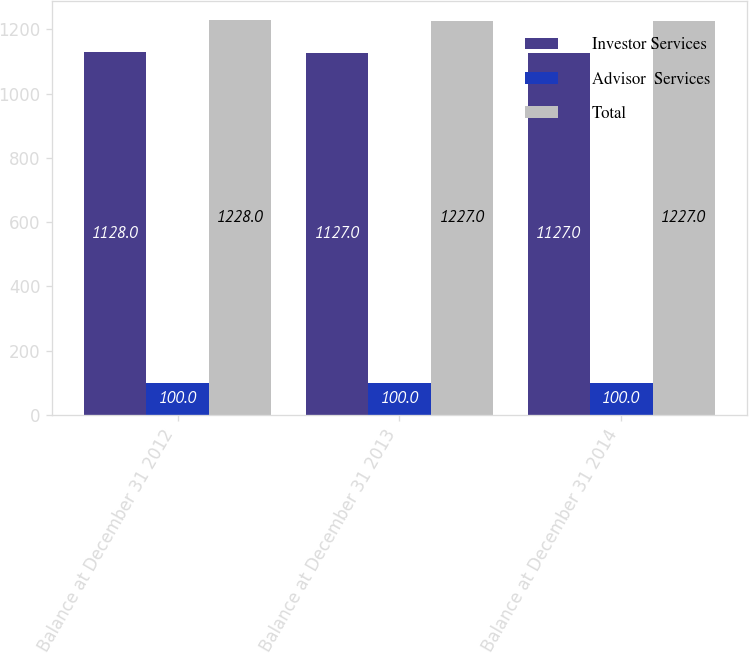Convert chart. <chart><loc_0><loc_0><loc_500><loc_500><stacked_bar_chart><ecel><fcel>Balance at December 31 2012<fcel>Balance at December 31 2013<fcel>Balance at December 31 2014<nl><fcel>Investor Services<fcel>1128<fcel>1127<fcel>1127<nl><fcel>Advisor  Services<fcel>100<fcel>100<fcel>100<nl><fcel>Total<fcel>1228<fcel>1227<fcel>1227<nl></chart> 